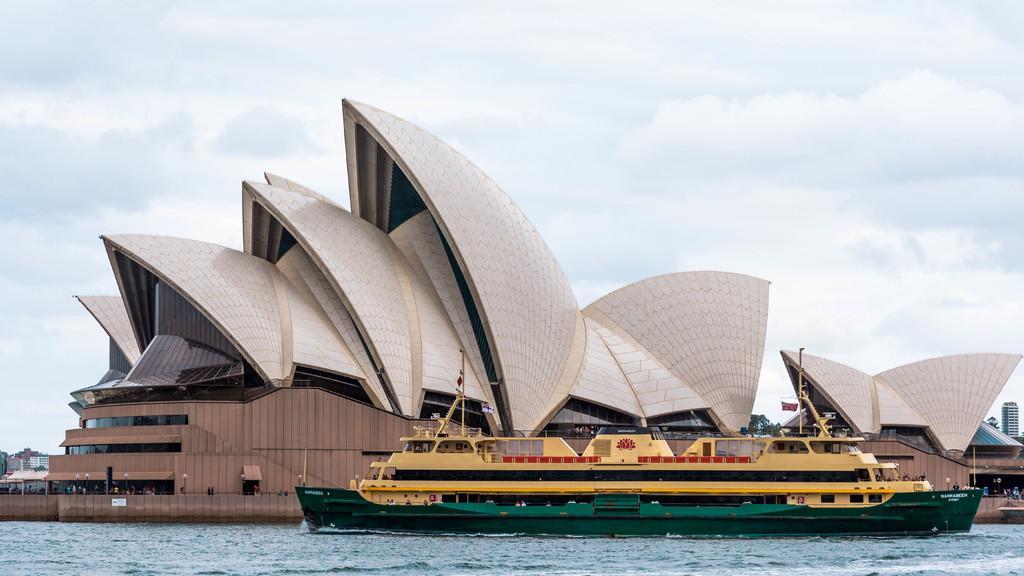Please provide a concise description of this image. In this image we can see a ship on the water. In the back there is a building. In the background there is sky with clouds. 